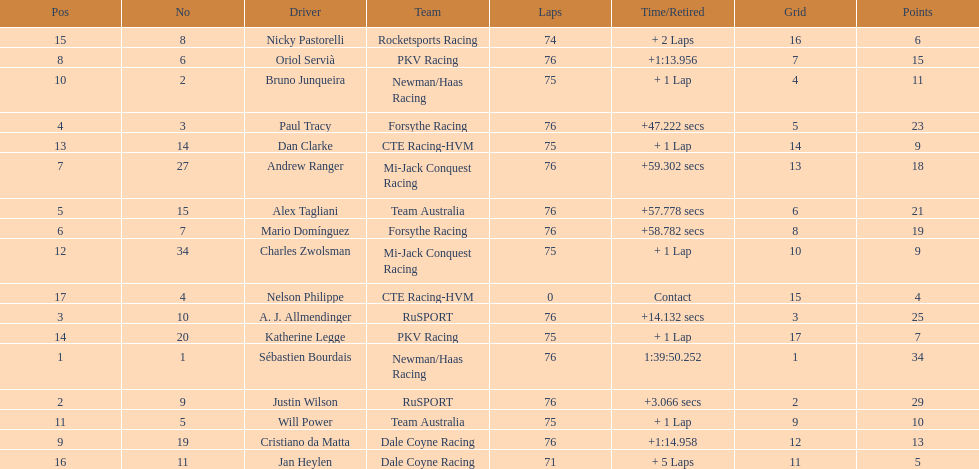Which driver has the least amount of points? Nelson Philippe. 